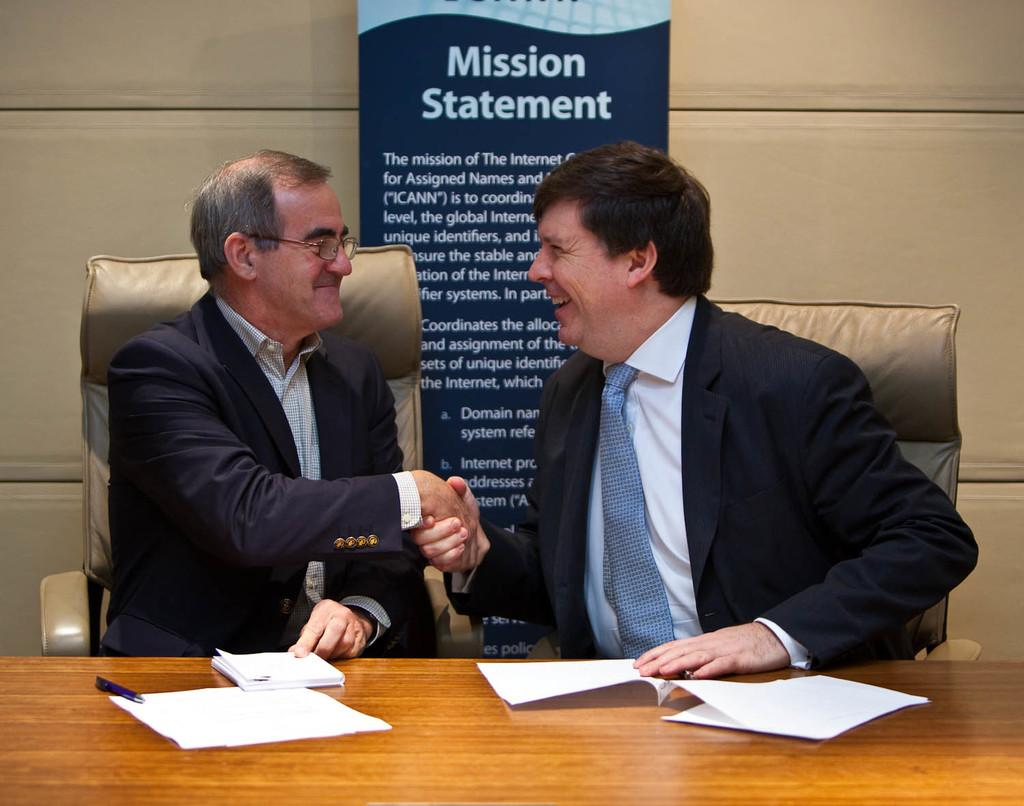What is the man in the image doing? The man is sitting on a chair in the image. What is the man wearing? The man is wearing a black coat. What is the man's facial expression? The man is smiling. Who is the man interacting with in the image? The man is shaking hands with another man. Where is the other man sitting in relation to the first man? The other man is sitting on the right side. What objects are on the table in the image? There are papers on the table. Are there any fairies present in the image? No, there are no fairies present in the image. How does the man express disgust in the image? The man does not express disgust in the image; he is smiling. 